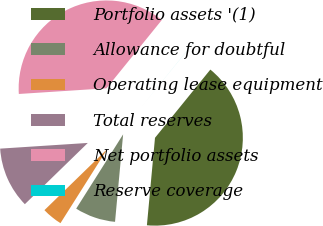Convert chart. <chart><loc_0><loc_0><loc_500><loc_500><pie_chart><fcel>Portfolio assets '(1)<fcel>Allowance for doubtful<fcel>Operating lease equipment<fcel>Total reserves<fcel>Net portfolio assets<fcel>Reserve coverage<nl><fcel>40.62%<fcel>7.5%<fcel>3.75%<fcel>11.25%<fcel>36.87%<fcel>0.01%<nl></chart> 